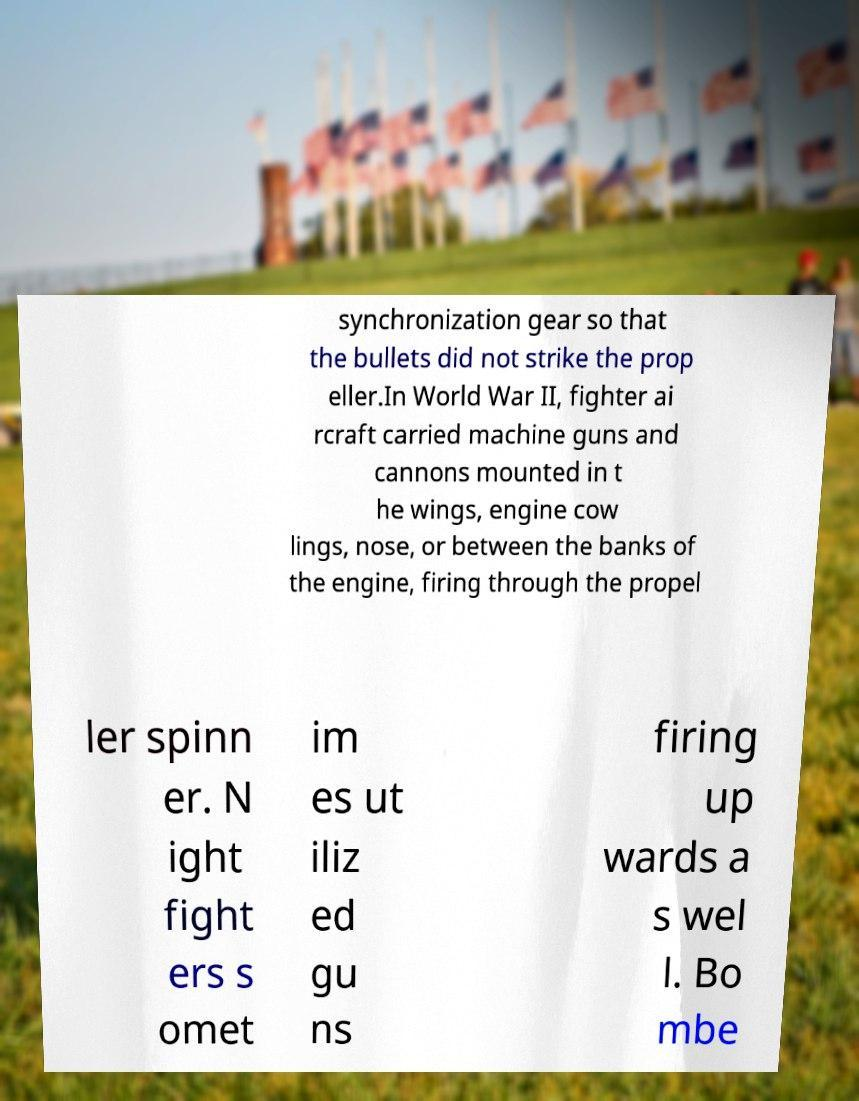Could you extract and type out the text from this image? synchronization gear so that the bullets did not strike the prop eller.In World War II, fighter ai rcraft carried machine guns and cannons mounted in t he wings, engine cow lings, nose, or between the banks of the engine, firing through the propel ler spinn er. N ight fight ers s omet im es ut iliz ed gu ns firing up wards a s wel l. Bo mbe 